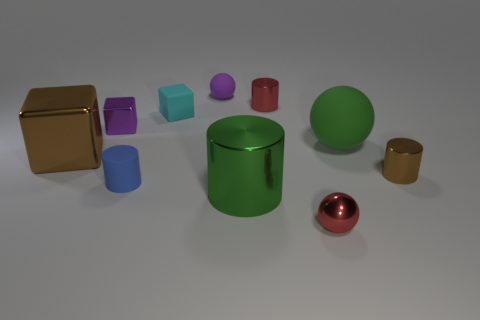What number of metallic things are either big green things or tiny cyan blocks?
Offer a very short reply. 1. There is a sphere to the right of the small red sphere; what is its size?
Your answer should be compact. Large. Is the shape of the large brown shiny object the same as the tiny cyan object?
Give a very brief answer. Yes. How many small things are cyan matte blocks or purple metal cubes?
Offer a very short reply. 2. There is a large green matte object; are there any cyan cubes behind it?
Your answer should be compact. Yes. Are there the same number of small objects in front of the small matte block and tiny brown metallic cylinders?
Make the answer very short. No. What is the size of the brown object that is the same shape as the small cyan thing?
Give a very brief answer. Large. Is the shape of the tiny cyan thing the same as the metal object behind the cyan block?
Provide a succinct answer. No. What is the size of the cylinder that is behind the brown thing right of the big matte object?
Offer a very short reply. Small. Are there an equal number of green matte spheres left of the tiny brown shiny object and large shiny objects behind the tiny purple sphere?
Give a very brief answer. No. 